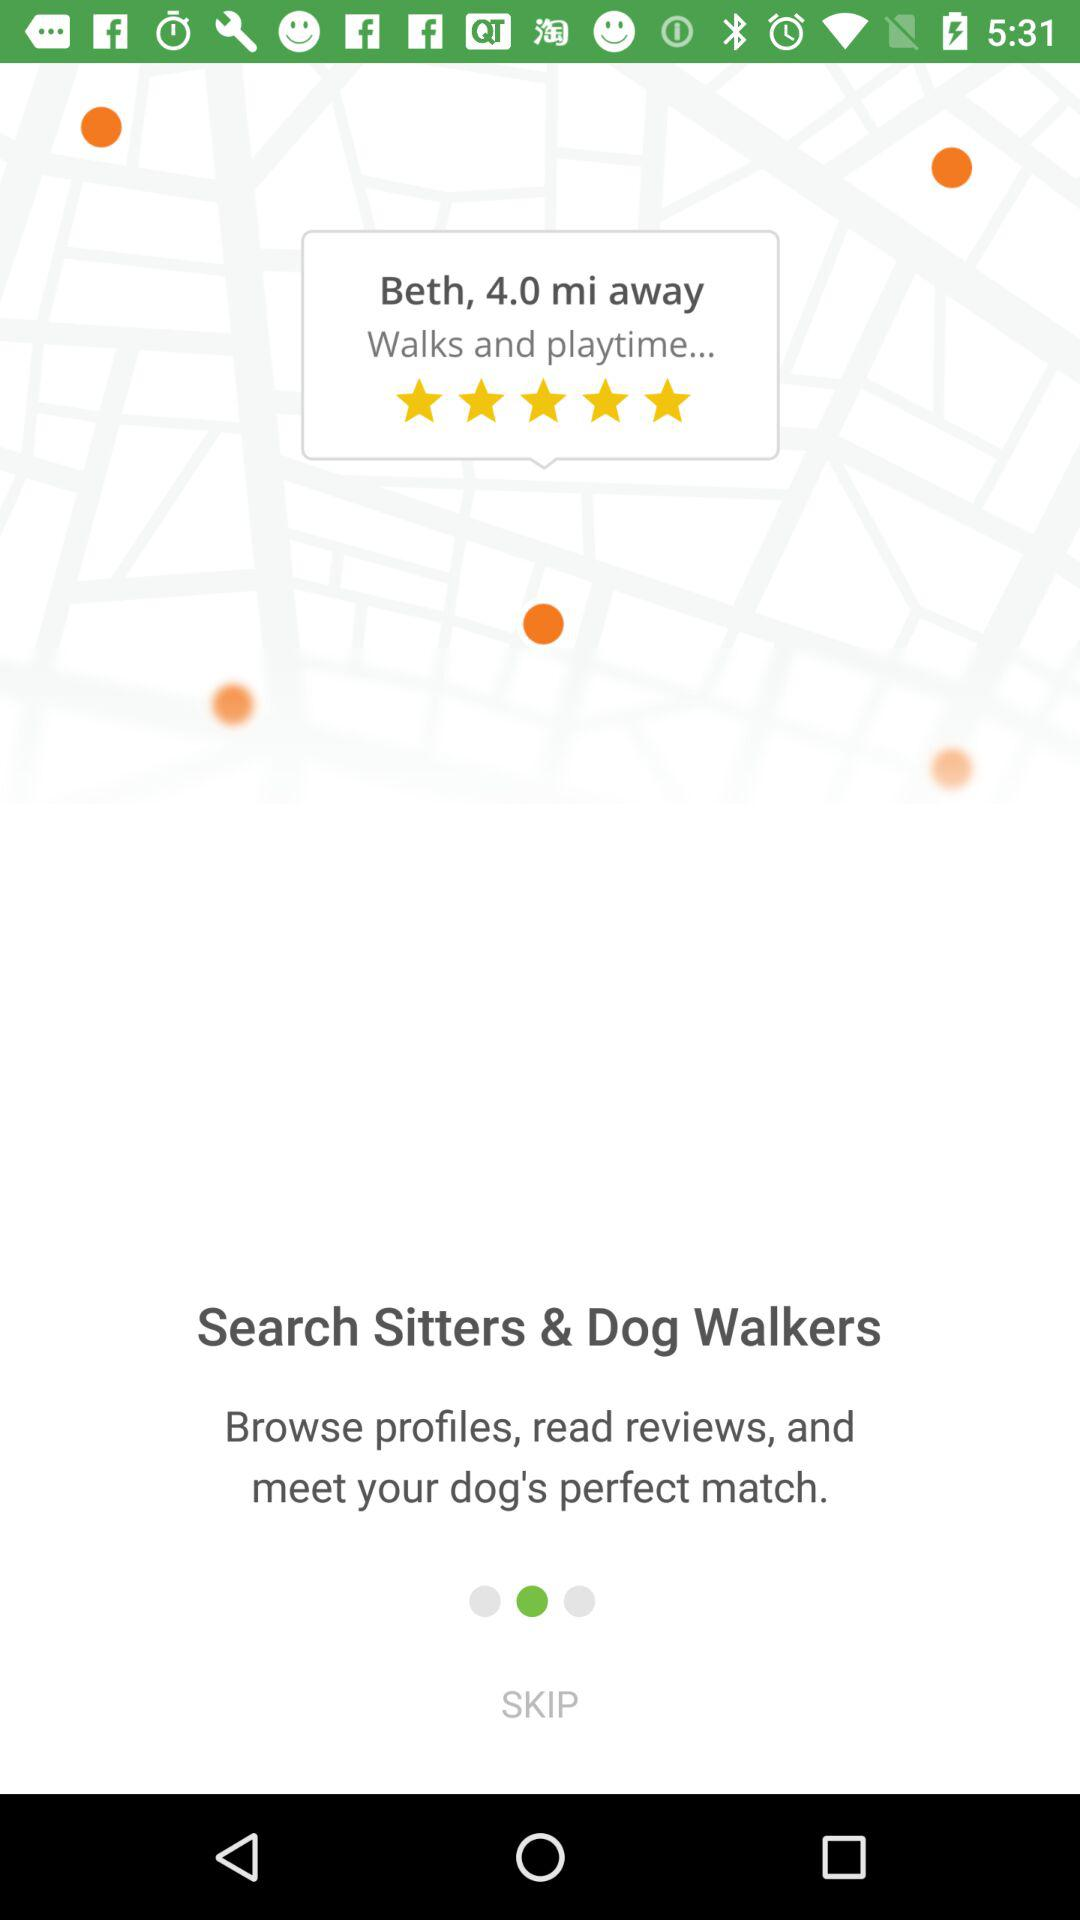How many miles away is Beth?
Answer the question using a single word or phrase. 4.0 